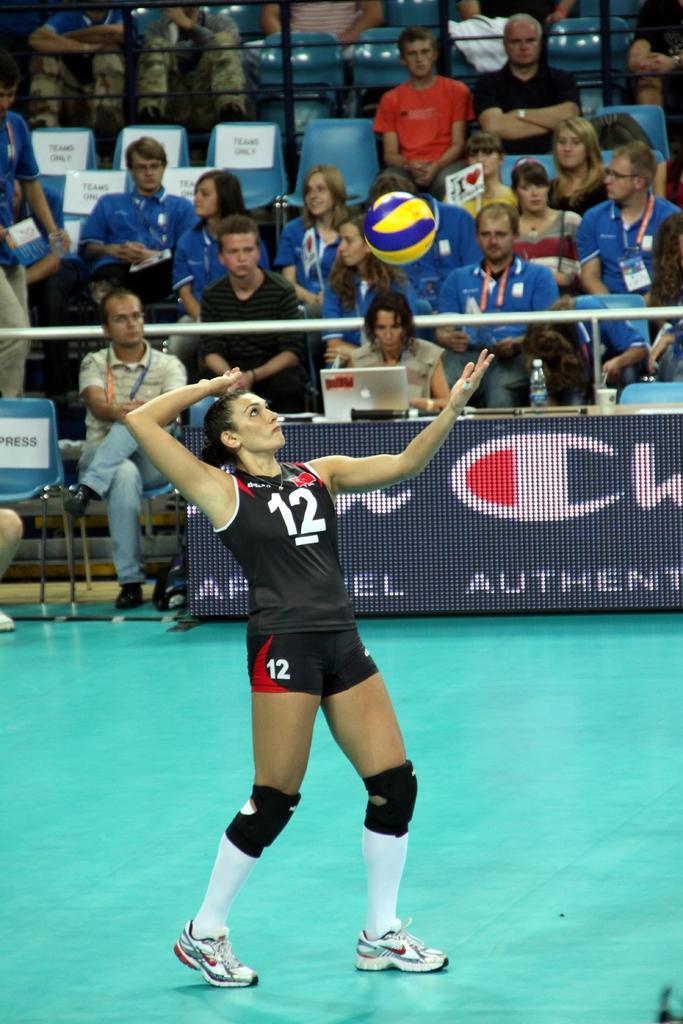Describe this image in one or two sentences. In this image I can see a woman is standing in the front and I can see she is wearing sports wear, knee guards, white socks and white shoes. I can see something is written on her dress. I can also see a ball in the air. In the background I can see a screen, a laptop, an iron pole and I can also see number of people are sitting on chairs. On the left side of this image I can see few white colour papers on the chairs and on it I can see something is written. I can also see something is written on the screen. 